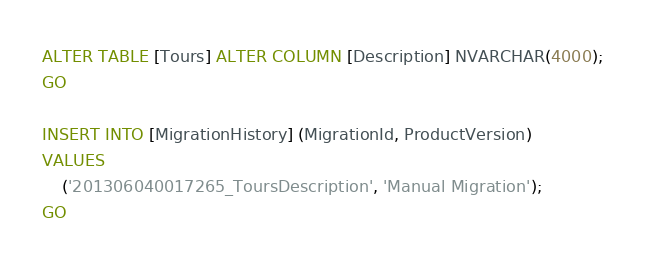<code> <loc_0><loc_0><loc_500><loc_500><_SQL_>ALTER TABLE [Tours] ALTER COLUMN [Description] NVARCHAR(4000);
GO

INSERT INTO [MigrationHistory] (MigrationId, ProductVersion)
VALUES
    ('201306040017265_ToursDescription', 'Manual Migration');
GO</code> 